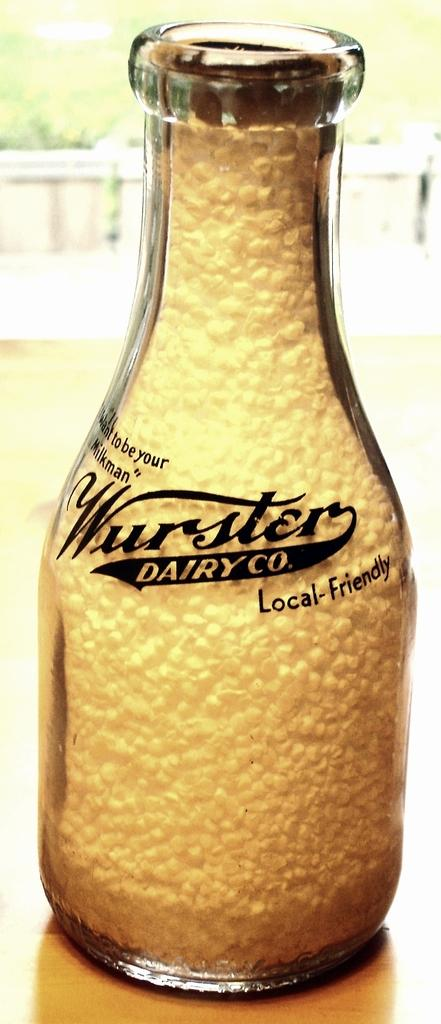<image>
Present a compact description of the photo's key features. A Wurster Dairy Co. glass bottle on a wooden table. 